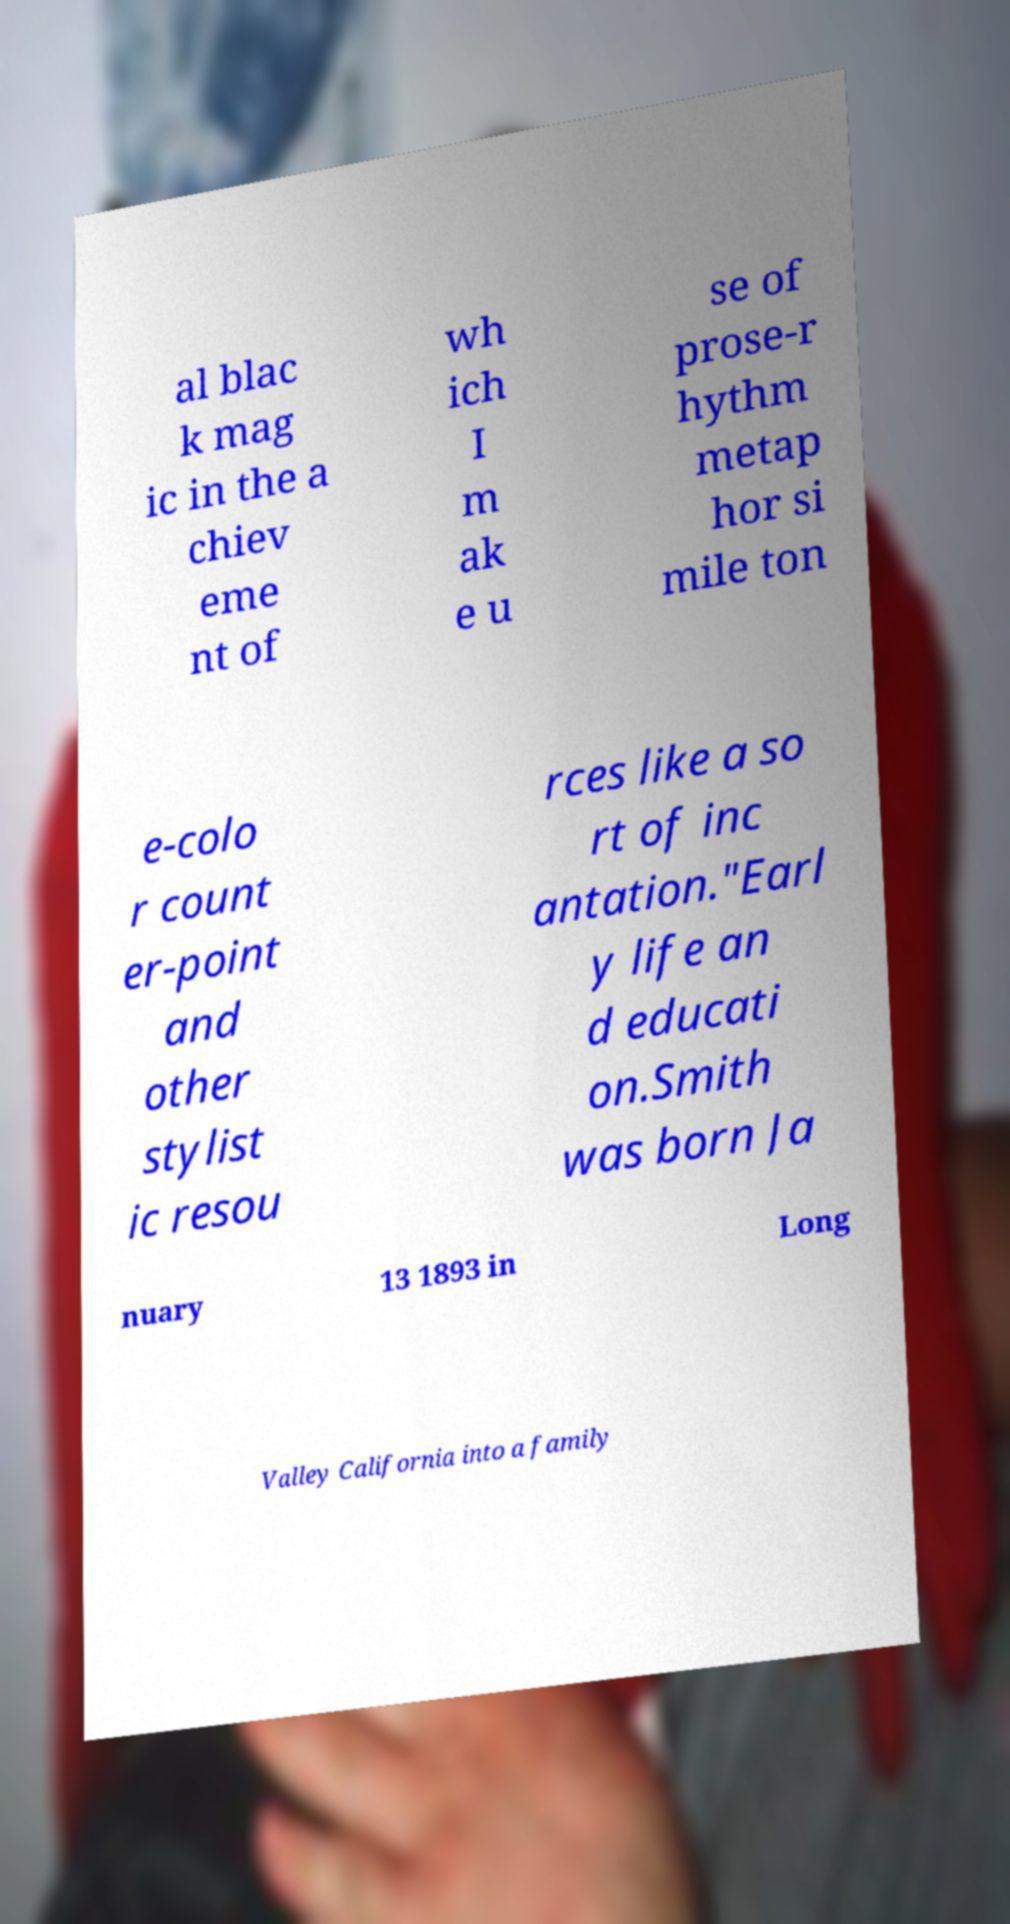For documentation purposes, I need the text within this image transcribed. Could you provide that? al blac k mag ic in the a chiev eme nt of wh ich I m ak e u se of prose-r hythm metap hor si mile ton e-colo r count er-point and other stylist ic resou rces like a so rt of inc antation."Earl y life an d educati on.Smith was born Ja nuary 13 1893 in Long Valley California into a family 